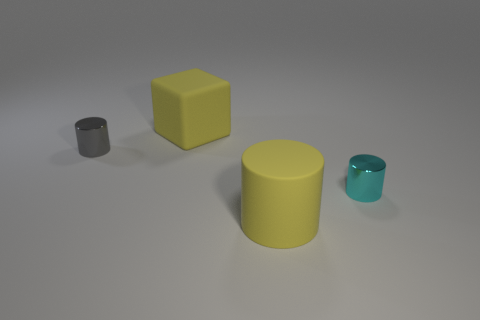If the yellow object is considered to be a reference, which object could represent a smaller counterpart in size? Given the yellow object as a reference, the cyan cylinder would represent a smaller counterpart in size. Can you infer anything about the relative weights of these objects? While we can't determine the exact weights from the image, if the objects are made from the same material, the yellow cube will likely be the heaviest due to its larger size, followed by the yellow cylinder, then the gray cylinder, and finally the cyan cylinder, which would be the lightest. 